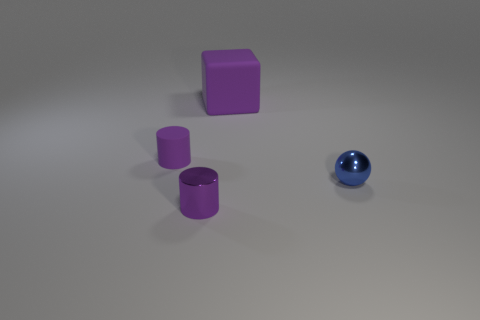How many things are either tiny metal objects to the right of the big purple block or metal spheres?
Your answer should be very brief. 1. What size is the thing that is both on the left side of the blue shiny object and in front of the purple rubber cylinder?
Your response must be concise. Small. The other rubber object that is the same color as the big thing is what size?
Provide a short and direct response. Small. What number of other objects are the same size as the metal ball?
Offer a very short reply. 2. What color is the metallic thing that is right of the block on the left side of the tiny metallic object to the right of the big thing?
Your answer should be compact. Blue. What is the shape of the purple thing that is in front of the cube and behind the blue thing?
Your response must be concise. Cylinder. How many other things are there of the same shape as the large thing?
Your response must be concise. 0. There is a purple thing in front of the metal object to the right of the tiny cylinder that is in front of the tiny purple rubber object; what is its shape?
Your answer should be very brief. Cylinder. How many things are tiny blue metallic things or small metal things on the left side of the blue sphere?
Your answer should be compact. 2. There is a tiny metallic object that is left of the large purple rubber object; is it the same shape as the object that is behind the purple rubber cylinder?
Make the answer very short. No. 